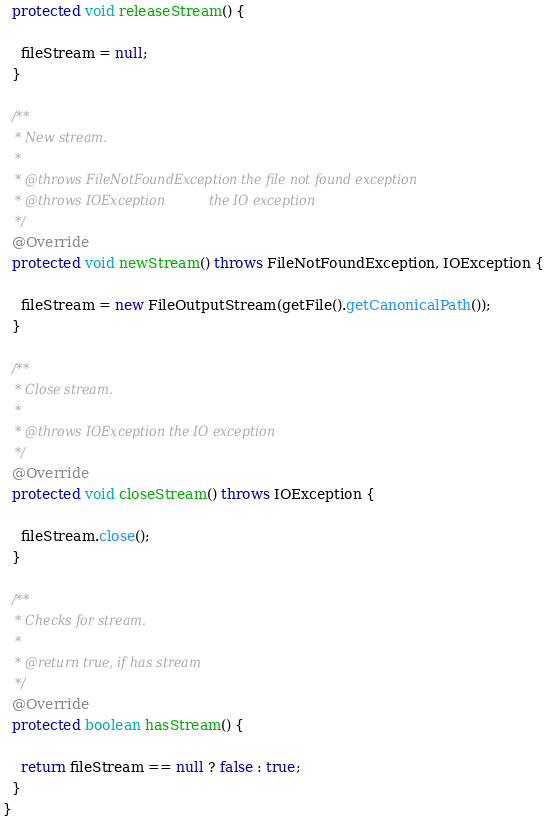<code> <loc_0><loc_0><loc_500><loc_500><_Java_>  protected void releaseStream() {

    fileStream = null;
  }

  /**
   * New stream.
   *
   * @throws FileNotFoundException the file not found exception
   * @throws IOException           the IO exception
   */
  @Override
  protected void newStream() throws FileNotFoundException, IOException {

    fileStream = new FileOutputStream(getFile().getCanonicalPath());
  }

  /**
   * Close stream.
   *
   * @throws IOException the IO exception
   */
  @Override
  protected void closeStream() throws IOException {

    fileStream.close();
  }

  /**
   * Checks for stream.
   *
   * @return true, if has stream
   */
  @Override
  protected boolean hasStream() {

    return fileStream == null ? false : true;
  }
}
</code> 